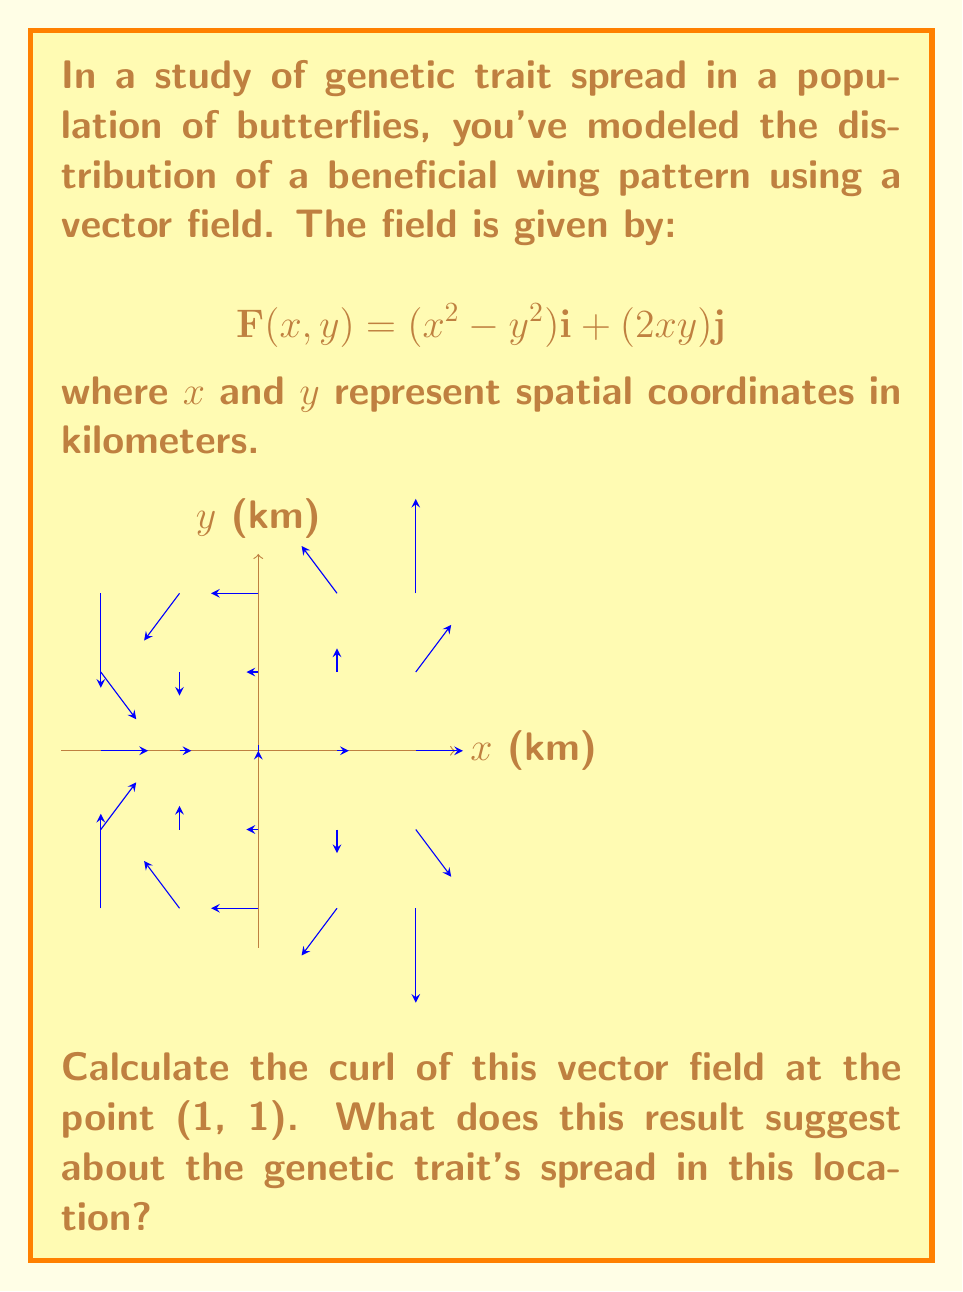What is the answer to this math problem? To solve this problem, we'll follow these steps:

1) The curl of a vector field $\mathbf{F}(x,y) = P(x,y)\mathbf{i} + Q(x,y)\mathbf{j}$ in two dimensions is given by:

   $$\text{curl }\mathbf{F} = \frac{\partial Q}{\partial x} - \frac{\partial P}{\partial y}$$

2) In our case:
   $P(x,y) = x^2 - y^2$
   $Q(x,y) = 2xy$

3) Let's calculate the partial derivatives:

   $\frac{\partial Q}{\partial x} = \frac{\partial}{\partial x}(2xy) = 2y$

   $\frac{\partial P}{\partial y} = \frac{\partial}{\partial y}(x^2 - y^2) = -2y$

4) Now we can calculate the curl:

   $$\text{curl }\mathbf{F} = \frac{\partial Q}{\partial x} - \frac{\partial P}{\partial y} = 2y - (-2y) = 4y$$

5) At the point (1, 1), we substitute y = 1:

   $$\text{curl }\mathbf{F}(1,1) = 4(1) = 4$$

6) Interpretation: The positive curl at (1, 1) indicates a counterclockwise rotation in the vector field at this point. In the context of genetic trait spread, this suggests that at this location, the trait is spreading in a way that creates a local vortex or circular pattern in the population distribution. This could indicate a hotspot of genetic diversity or a particularly strong selective pressure at this location.
Answer: Curl = 4; indicates counterclockwise rotation, suggesting localized circular spread of the genetic trait. 